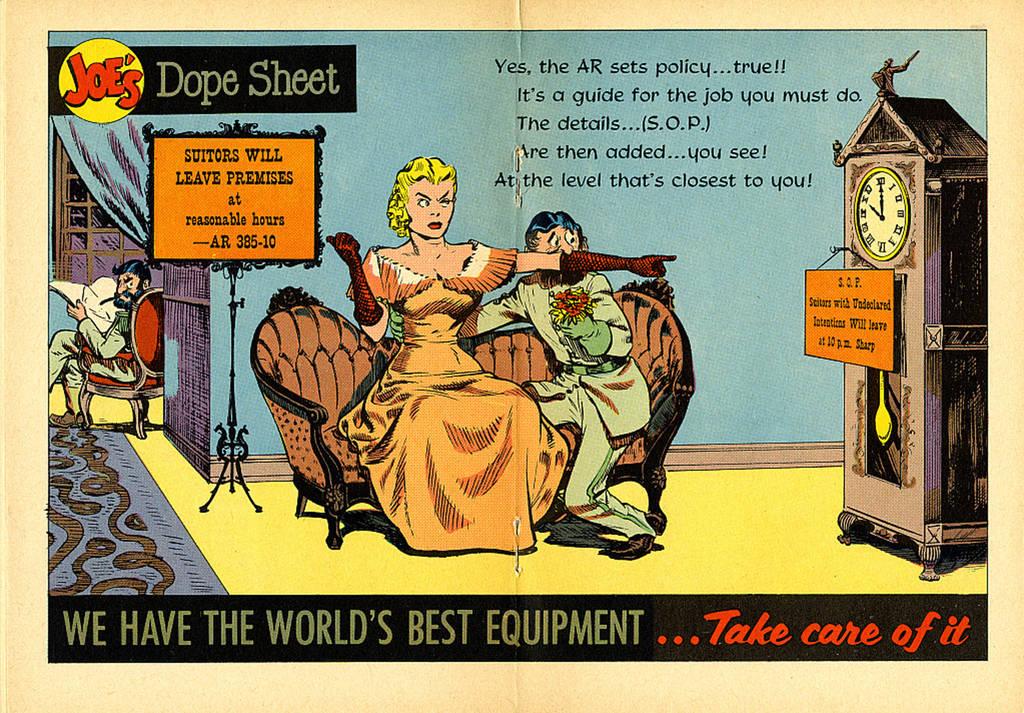What brand is this?
Ensure brevity in your answer.  Joe's. What does the red letters on the right bottom say?
Offer a terse response. Take care of it. 